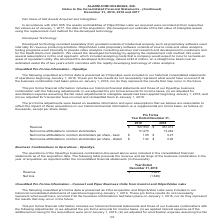From Alarmcom Holdings's financial document, Which years does the table provide information for revenue? The document shows two values: 2019 and 2018. From the document: "Pro Forma Year Ended December 31, 2019 2018 Revenue $ 527,550 $ 451,013 Net income attributable to common stockholders 51,075 13,264 Net i Pro Forma Y..." Also, What was the net income attributable to common stockholders in 2018? According to the financial document, 13,264 (in thousands). The relevant text states: "income attributable to common stockholders 51,075 13,264 Net income attributable to common stockholders per share - basic $ 1.05 $ 0.27 Net income attributa..." Also, What was the Net income attributable to common stockholders per share - basic in 2019? According to the financial document, $1.05. The relevant text states: "utable to common stockholders per share - basic $ 1.05 $ 0.27 Net income attributable to common stockholders per share - diluted $ 1.02 $ 0.26..." Also, can you calculate: What was the change in the Net income attributable to common stockholders per share - diluted between 2018 and 2019? Based on the calculation: 1.02-0.26, the result is 0.76. This is based on the information: "common stockholders per share - diluted $ 1.02 $ 0.26 able to common stockholders per share - diluted $ 1.02 $ 0.26..." The key data points involved are: 0.26, 1.02. Also, can you calculate: What was the change in the Net income attributable to common stockholders between 2018 and 2019? Based on the calculation: 51,075-13,264, the result is 37811 (in thousands). This is based on the information: "13 Net income attributable to common stockholders 51,075 13,264 Net income attributable to common stockholders per share - basic $ 1.05 $ 0.27 Net income at income attributable to common stockholders ..." The key data points involved are: 13,264, 51,075. Also, can you calculate: What was the percentage change in the revenue between 2018 and 2019? To answer this question, I need to perform calculations using the financial data. The calculation is: (527,550-451,013)/451,013, which equals 16.97 (percentage). This is based on the information: "Forma Year Ended December 31, 2019 2018 Revenue $ 527,550 $ 451,013 Net income attributable to common stockholders 51,075 13,264 Net income attributable to c Ended December 31, 2019 2018 Revenue $ 527..." The key data points involved are: 451,013, 527,550. 